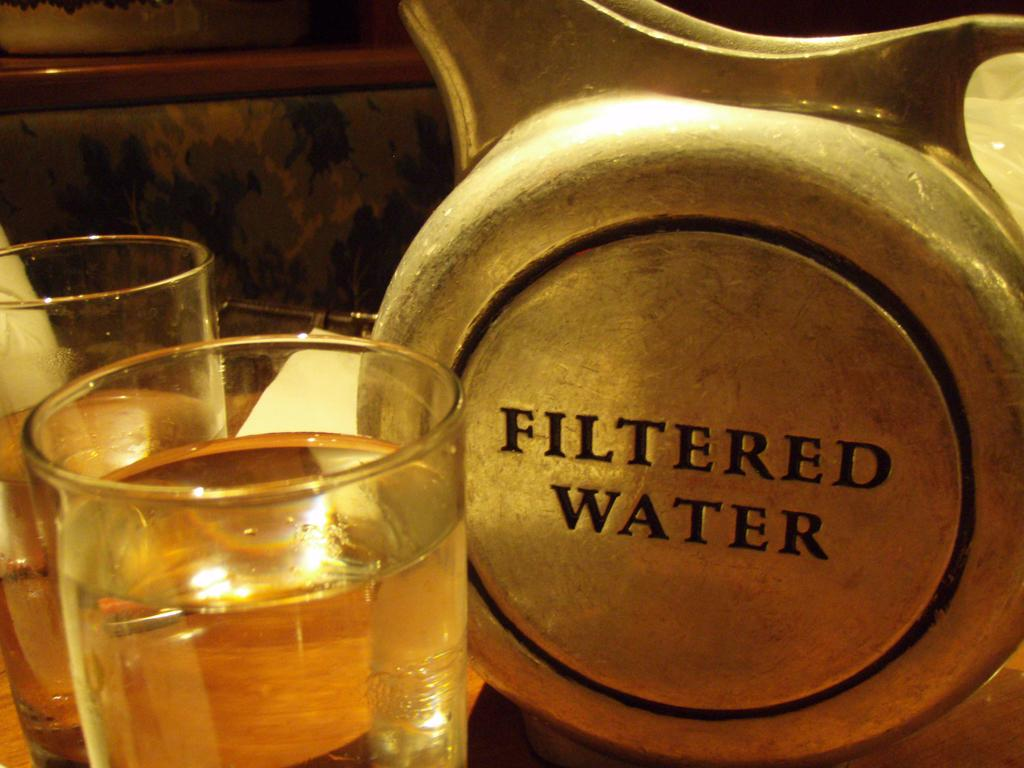<image>
Offer a succinct explanation of the picture presented. A silver container that says Filtered Water is next to two glasses of water. 